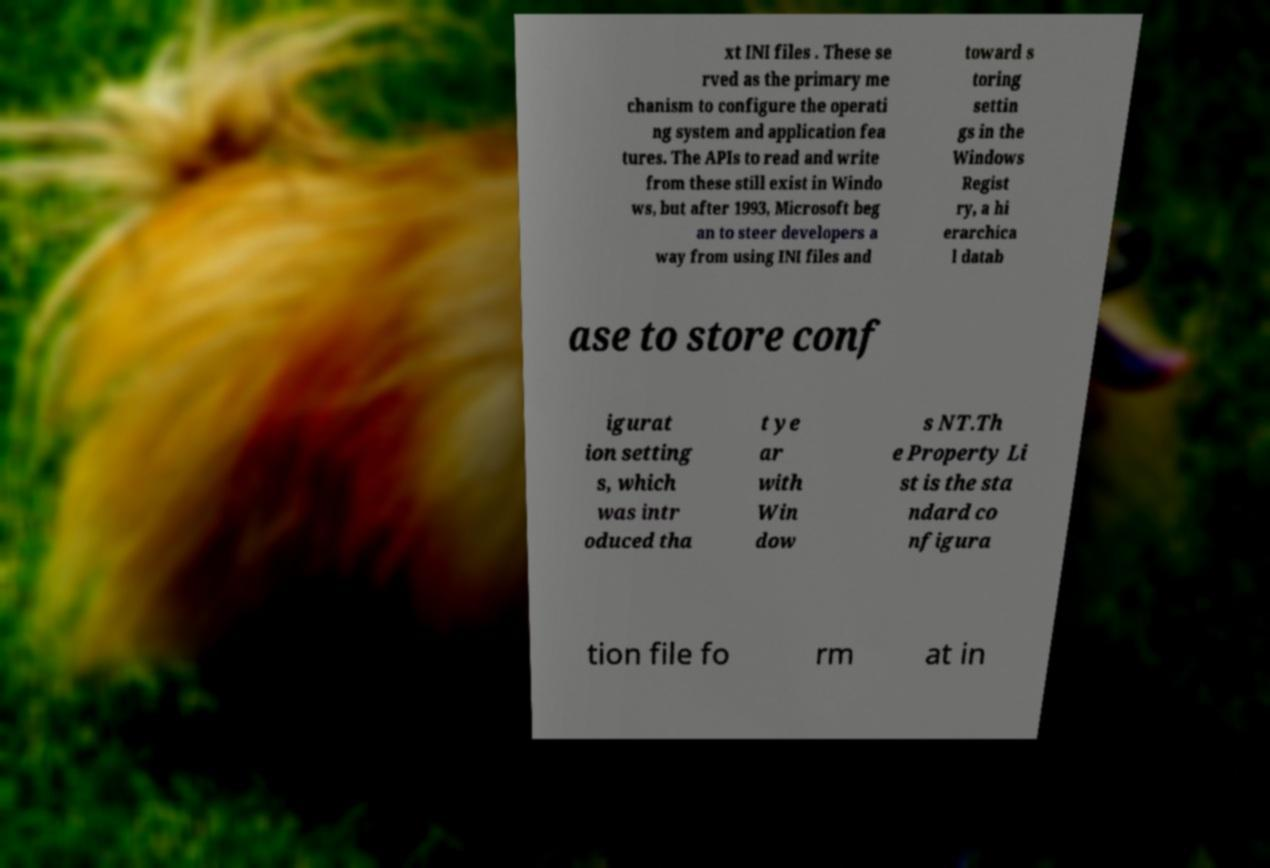For documentation purposes, I need the text within this image transcribed. Could you provide that? xt INI files . These se rved as the primary me chanism to configure the operati ng system and application fea tures. The APIs to read and write from these still exist in Windo ws, but after 1993, Microsoft beg an to steer developers a way from using INI files and toward s toring settin gs in the Windows Regist ry, a hi erarchica l datab ase to store conf igurat ion setting s, which was intr oduced tha t ye ar with Win dow s NT.Th e Property Li st is the sta ndard co nfigura tion file fo rm at in 